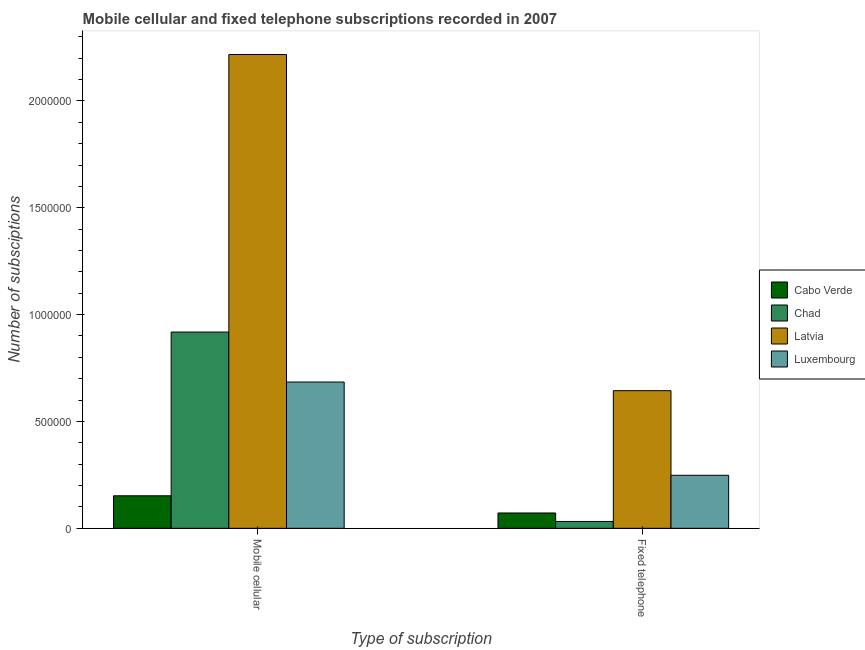How many different coloured bars are there?
Provide a succinct answer. 4. Are the number of bars on each tick of the X-axis equal?
Your answer should be very brief. Yes. How many bars are there on the 1st tick from the left?
Your answer should be compact. 4. How many bars are there on the 1st tick from the right?
Give a very brief answer. 4. What is the label of the 2nd group of bars from the left?
Your answer should be compact. Fixed telephone. What is the number of mobile cellular subscriptions in Latvia?
Offer a very short reply. 2.22e+06. Across all countries, what is the maximum number of mobile cellular subscriptions?
Give a very brief answer. 2.22e+06. Across all countries, what is the minimum number of mobile cellular subscriptions?
Ensure brevity in your answer.  1.52e+05. In which country was the number of mobile cellular subscriptions maximum?
Your answer should be very brief. Latvia. In which country was the number of fixed telephone subscriptions minimum?
Provide a succinct answer. Chad. What is the total number of mobile cellular subscriptions in the graph?
Offer a terse response. 3.97e+06. What is the difference between the number of fixed telephone subscriptions in Cabo Verde and that in Chad?
Offer a terse response. 3.98e+04. What is the difference between the number of fixed telephone subscriptions in Chad and the number of mobile cellular subscriptions in Luxembourg?
Ensure brevity in your answer.  -6.52e+05. What is the average number of mobile cellular subscriptions per country?
Keep it short and to the point. 9.93e+05. What is the difference between the number of mobile cellular subscriptions and number of fixed telephone subscriptions in Luxembourg?
Keep it short and to the point. 4.36e+05. What is the ratio of the number of mobile cellular subscriptions in Chad to that in Cabo Verde?
Ensure brevity in your answer.  6.03. Is the number of mobile cellular subscriptions in Luxembourg less than that in Latvia?
Provide a short and direct response. Yes. What does the 1st bar from the left in Mobile cellular represents?
Offer a very short reply. Cabo Verde. What does the 1st bar from the right in Mobile cellular represents?
Your response must be concise. Luxembourg. How many bars are there?
Offer a terse response. 8. What is the difference between two consecutive major ticks on the Y-axis?
Offer a very short reply. 5.00e+05. Are the values on the major ticks of Y-axis written in scientific E-notation?
Provide a short and direct response. No. Where does the legend appear in the graph?
Ensure brevity in your answer.  Center right. How many legend labels are there?
Keep it short and to the point. 4. What is the title of the graph?
Your response must be concise. Mobile cellular and fixed telephone subscriptions recorded in 2007. What is the label or title of the X-axis?
Ensure brevity in your answer.  Type of subscription. What is the label or title of the Y-axis?
Provide a short and direct response. Number of subsciptions. What is the Number of subsciptions in Cabo Verde in Mobile cellular?
Give a very brief answer. 1.52e+05. What is the Number of subsciptions in Chad in Mobile cellular?
Your answer should be very brief. 9.18e+05. What is the Number of subsciptions in Latvia in Mobile cellular?
Your answer should be very brief. 2.22e+06. What is the Number of subsciptions in Luxembourg in Mobile cellular?
Provide a short and direct response. 6.84e+05. What is the Number of subsciptions of Cabo Verde in Fixed telephone?
Keep it short and to the point. 7.18e+04. What is the Number of subsciptions in Chad in Fixed telephone?
Offer a terse response. 3.20e+04. What is the Number of subsciptions in Latvia in Fixed telephone?
Provide a succinct answer. 6.44e+05. What is the Number of subsciptions of Luxembourg in Fixed telephone?
Make the answer very short. 2.48e+05. Across all Type of subscription, what is the maximum Number of subsciptions of Cabo Verde?
Your response must be concise. 1.52e+05. Across all Type of subscription, what is the maximum Number of subsciptions of Chad?
Your answer should be compact. 9.18e+05. Across all Type of subscription, what is the maximum Number of subsciptions of Latvia?
Provide a succinct answer. 2.22e+06. Across all Type of subscription, what is the maximum Number of subsciptions of Luxembourg?
Make the answer very short. 6.84e+05. Across all Type of subscription, what is the minimum Number of subsciptions of Cabo Verde?
Provide a succinct answer. 7.18e+04. Across all Type of subscription, what is the minimum Number of subsciptions of Chad?
Your answer should be very brief. 3.20e+04. Across all Type of subscription, what is the minimum Number of subsciptions in Latvia?
Make the answer very short. 6.44e+05. Across all Type of subscription, what is the minimum Number of subsciptions of Luxembourg?
Your answer should be compact. 2.48e+05. What is the total Number of subsciptions of Cabo Verde in the graph?
Make the answer very short. 2.24e+05. What is the total Number of subsciptions in Chad in the graph?
Give a very brief answer. 9.50e+05. What is the total Number of subsciptions of Latvia in the graph?
Give a very brief answer. 2.86e+06. What is the total Number of subsciptions of Luxembourg in the graph?
Provide a succinct answer. 9.33e+05. What is the difference between the Number of subsciptions of Cabo Verde in Mobile cellular and that in Fixed telephone?
Make the answer very short. 8.04e+04. What is the difference between the Number of subsciptions in Chad in Mobile cellular and that in Fixed telephone?
Provide a succinct answer. 8.86e+05. What is the difference between the Number of subsciptions of Latvia in Mobile cellular and that in Fixed telephone?
Ensure brevity in your answer.  1.57e+06. What is the difference between the Number of subsciptions of Luxembourg in Mobile cellular and that in Fixed telephone?
Provide a succinct answer. 4.36e+05. What is the difference between the Number of subsciptions of Cabo Verde in Mobile cellular and the Number of subsciptions of Chad in Fixed telephone?
Make the answer very short. 1.20e+05. What is the difference between the Number of subsciptions in Cabo Verde in Mobile cellular and the Number of subsciptions in Latvia in Fixed telephone?
Your response must be concise. -4.92e+05. What is the difference between the Number of subsciptions of Cabo Verde in Mobile cellular and the Number of subsciptions of Luxembourg in Fixed telephone?
Make the answer very short. -9.60e+04. What is the difference between the Number of subsciptions of Chad in Mobile cellular and the Number of subsciptions of Latvia in Fixed telephone?
Give a very brief answer. 2.74e+05. What is the difference between the Number of subsciptions in Chad in Mobile cellular and the Number of subsciptions in Luxembourg in Fixed telephone?
Give a very brief answer. 6.70e+05. What is the difference between the Number of subsciptions of Latvia in Mobile cellular and the Number of subsciptions of Luxembourg in Fixed telephone?
Offer a terse response. 1.97e+06. What is the average Number of subsciptions in Cabo Verde per Type of subscription?
Give a very brief answer. 1.12e+05. What is the average Number of subsciptions of Chad per Type of subscription?
Offer a terse response. 4.75e+05. What is the average Number of subsciptions of Latvia per Type of subscription?
Your answer should be very brief. 1.43e+06. What is the average Number of subsciptions of Luxembourg per Type of subscription?
Offer a very short reply. 4.66e+05. What is the difference between the Number of subsciptions of Cabo Verde and Number of subsciptions of Chad in Mobile cellular?
Provide a short and direct response. -7.66e+05. What is the difference between the Number of subsciptions of Cabo Verde and Number of subsciptions of Latvia in Mobile cellular?
Keep it short and to the point. -2.06e+06. What is the difference between the Number of subsciptions of Cabo Verde and Number of subsciptions of Luxembourg in Mobile cellular?
Your answer should be very brief. -5.32e+05. What is the difference between the Number of subsciptions of Chad and Number of subsciptions of Latvia in Mobile cellular?
Offer a terse response. -1.30e+06. What is the difference between the Number of subsciptions of Chad and Number of subsciptions of Luxembourg in Mobile cellular?
Give a very brief answer. 2.34e+05. What is the difference between the Number of subsciptions of Latvia and Number of subsciptions of Luxembourg in Mobile cellular?
Your response must be concise. 1.53e+06. What is the difference between the Number of subsciptions in Cabo Verde and Number of subsciptions in Chad in Fixed telephone?
Provide a short and direct response. 3.98e+04. What is the difference between the Number of subsciptions of Cabo Verde and Number of subsciptions of Latvia in Fixed telephone?
Provide a succinct answer. -5.72e+05. What is the difference between the Number of subsciptions in Cabo Verde and Number of subsciptions in Luxembourg in Fixed telephone?
Make the answer very short. -1.76e+05. What is the difference between the Number of subsciptions of Chad and Number of subsciptions of Latvia in Fixed telephone?
Your answer should be very brief. -6.12e+05. What is the difference between the Number of subsciptions in Chad and Number of subsciptions in Luxembourg in Fixed telephone?
Give a very brief answer. -2.16e+05. What is the difference between the Number of subsciptions of Latvia and Number of subsciptions of Luxembourg in Fixed telephone?
Ensure brevity in your answer.  3.96e+05. What is the ratio of the Number of subsciptions of Cabo Verde in Mobile cellular to that in Fixed telephone?
Ensure brevity in your answer.  2.12. What is the ratio of the Number of subsciptions in Chad in Mobile cellular to that in Fixed telephone?
Offer a terse response. 28.7. What is the ratio of the Number of subsciptions in Latvia in Mobile cellular to that in Fixed telephone?
Give a very brief answer. 3.44. What is the ratio of the Number of subsciptions in Luxembourg in Mobile cellular to that in Fixed telephone?
Your answer should be very brief. 2.76. What is the difference between the highest and the second highest Number of subsciptions of Cabo Verde?
Your response must be concise. 8.04e+04. What is the difference between the highest and the second highest Number of subsciptions in Chad?
Ensure brevity in your answer.  8.86e+05. What is the difference between the highest and the second highest Number of subsciptions of Latvia?
Your answer should be compact. 1.57e+06. What is the difference between the highest and the second highest Number of subsciptions of Luxembourg?
Provide a short and direct response. 4.36e+05. What is the difference between the highest and the lowest Number of subsciptions in Cabo Verde?
Provide a succinct answer. 8.04e+04. What is the difference between the highest and the lowest Number of subsciptions of Chad?
Offer a very short reply. 8.86e+05. What is the difference between the highest and the lowest Number of subsciptions of Latvia?
Your answer should be compact. 1.57e+06. What is the difference between the highest and the lowest Number of subsciptions in Luxembourg?
Offer a terse response. 4.36e+05. 